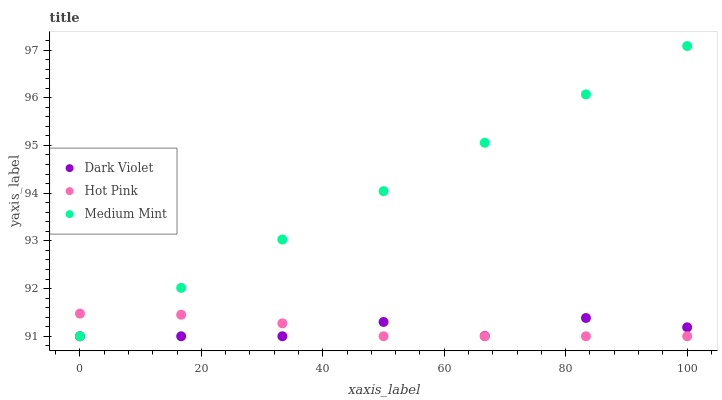Does Dark Violet have the minimum area under the curve?
Answer yes or no. Yes. Does Medium Mint have the maximum area under the curve?
Answer yes or no. Yes. Does Hot Pink have the minimum area under the curve?
Answer yes or no. No. Does Hot Pink have the maximum area under the curve?
Answer yes or no. No. Is Medium Mint the smoothest?
Answer yes or no. Yes. Is Dark Violet the roughest?
Answer yes or no. Yes. Is Hot Pink the smoothest?
Answer yes or no. No. Is Hot Pink the roughest?
Answer yes or no. No. Does Medium Mint have the lowest value?
Answer yes or no. Yes. Does Medium Mint have the highest value?
Answer yes or no. Yes. Does Hot Pink have the highest value?
Answer yes or no. No. Does Dark Violet intersect Medium Mint?
Answer yes or no. Yes. Is Dark Violet less than Medium Mint?
Answer yes or no. No. Is Dark Violet greater than Medium Mint?
Answer yes or no. No. 